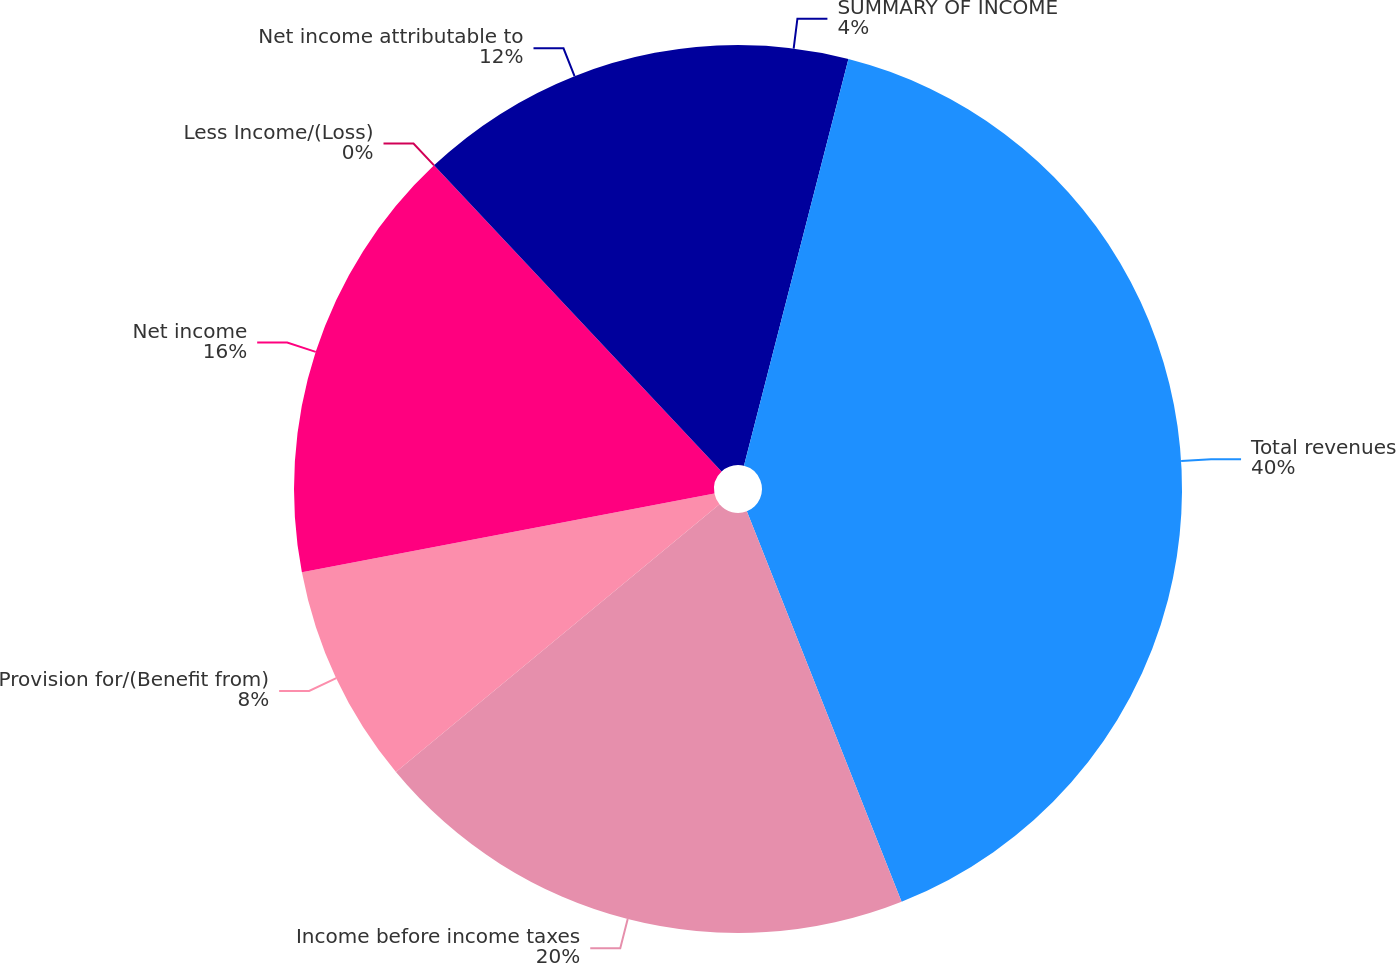Convert chart. <chart><loc_0><loc_0><loc_500><loc_500><pie_chart><fcel>SUMMARY OF INCOME<fcel>Total revenues<fcel>Income before income taxes<fcel>Provision for/(Benefit from)<fcel>Net income<fcel>Less Income/(Loss)<fcel>Net income attributable to<nl><fcel>4.0%<fcel>39.99%<fcel>20.0%<fcel>8.0%<fcel>16.0%<fcel>0.0%<fcel>12.0%<nl></chart> 